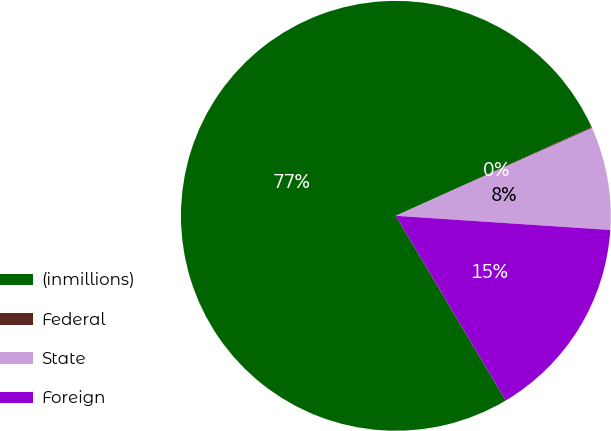Convert chart. <chart><loc_0><loc_0><loc_500><loc_500><pie_chart><fcel>(inmillions)<fcel>Federal<fcel>State<fcel>Foreign<nl><fcel>76.76%<fcel>0.08%<fcel>7.75%<fcel>15.41%<nl></chart> 